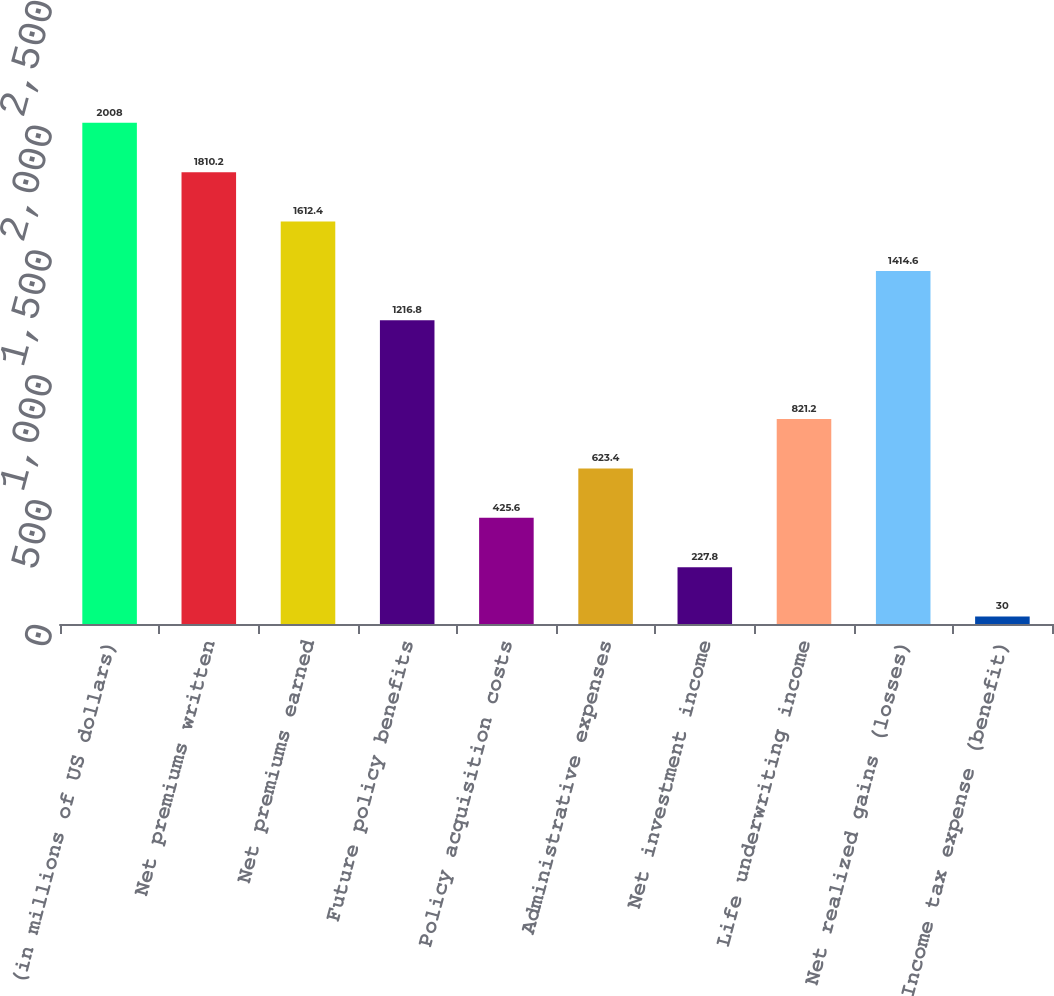Convert chart to OTSL. <chart><loc_0><loc_0><loc_500><loc_500><bar_chart><fcel>(in millions of US dollars)<fcel>Net premiums written<fcel>Net premiums earned<fcel>Future policy benefits<fcel>Policy acquisition costs<fcel>Administrative expenses<fcel>Net investment income<fcel>Life underwriting income<fcel>Net realized gains (losses)<fcel>Income tax expense (benefit)<nl><fcel>2008<fcel>1810.2<fcel>1612.4<fcel>1216.8<fcel>425.6<fcel>623.4<fcel>227.8<fcel>821.2<fcel>1414.6<fcel>30<nl></chart> 